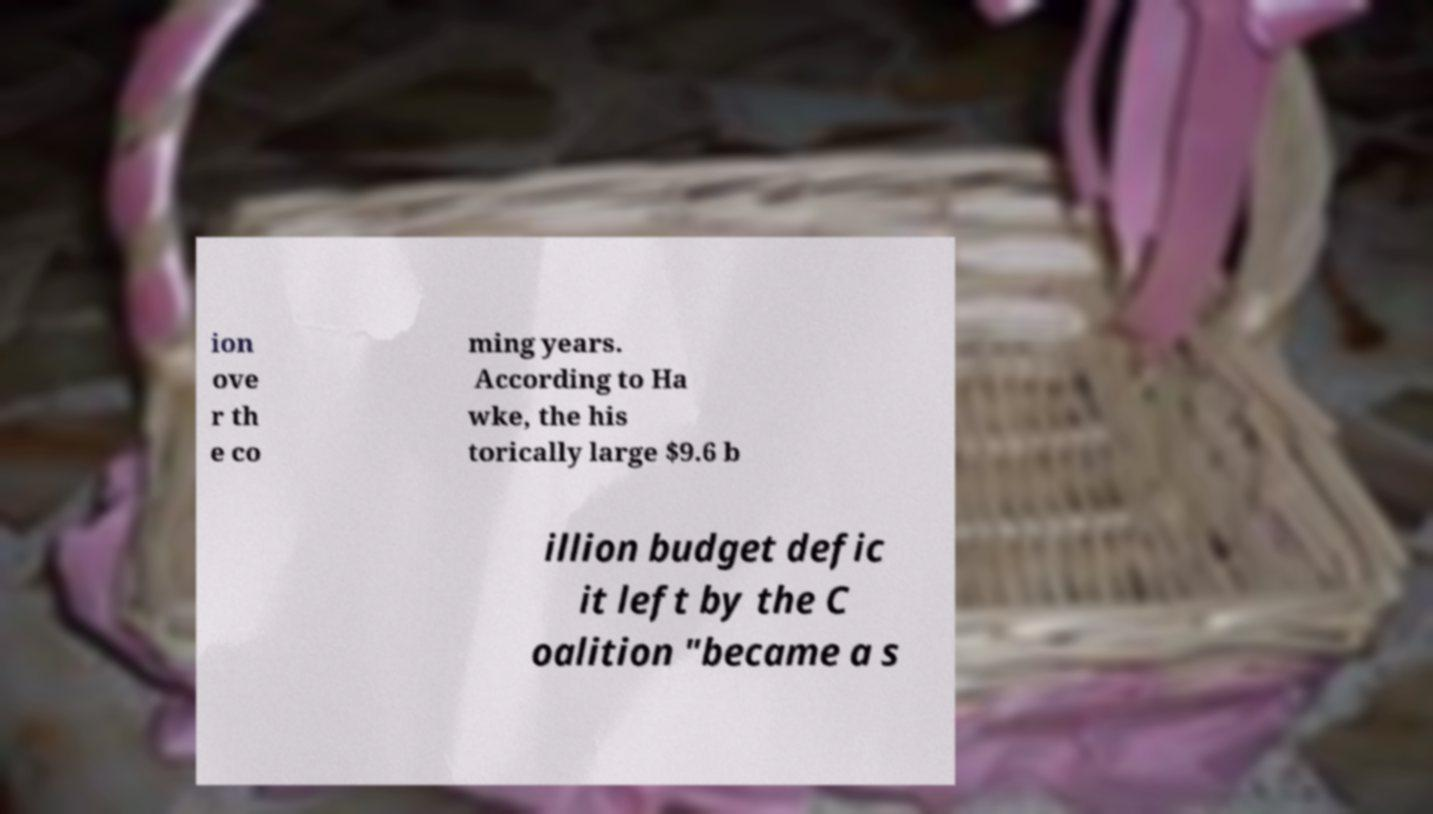Could you extract and type out the text from this image? ion ove r th e co ming years. According to Ha wke, the his torically large $9.6 b illion budget defic it left by the C oalition "became a s 